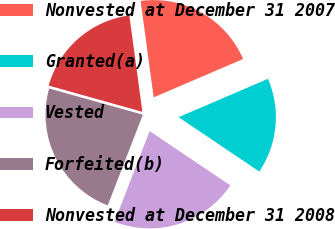Convert chart to OTSL. <chart><loc_0><loc_0><loc_500><loc_500><pie_chart><fcel>Nonvested at December 31 2007<fcel>Granted(a)<fcel>Vested<fcel>Forfeited(b)<fcel>Nonvested at December 31 2008<nl><fcel>20.69%<fcel>15.88%<fcel>21.45%<fcel>23.47%<fcel>18.51%<nl></chart> 